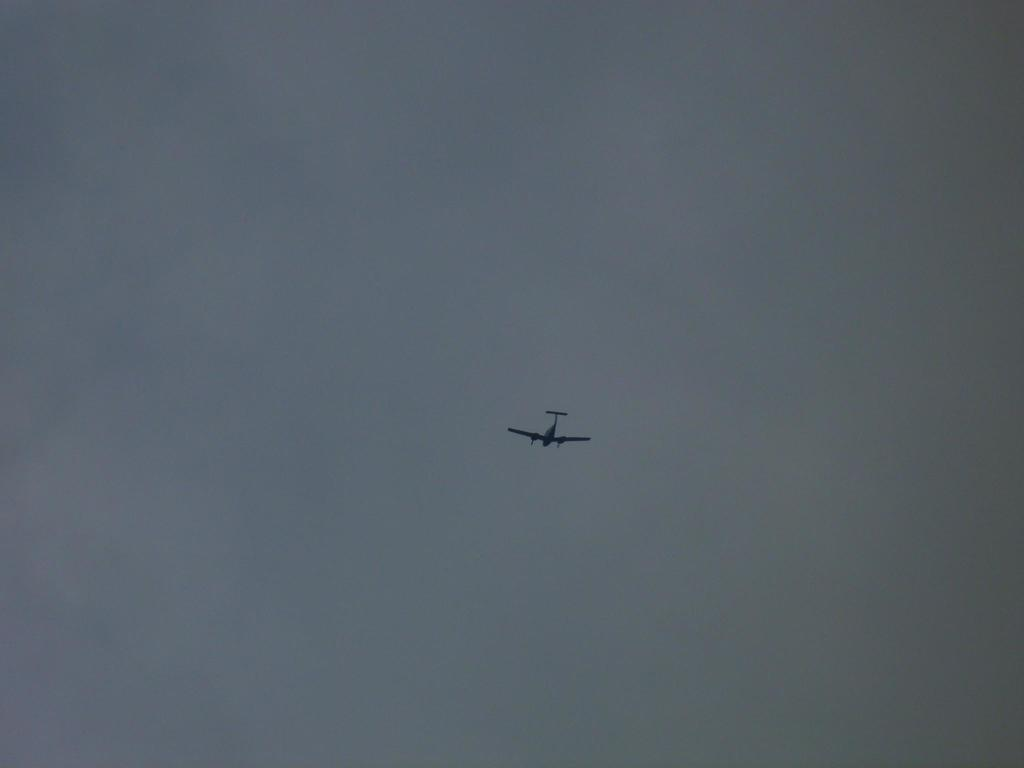What is the main subject in the foreground of the image? There is a plane in the air in the foreground of the image. What can be seen in the background of the image? The sky is visible in the background of the image. What type of nail is being used to hold the plate in the image? There is no nail or plate present in the image; it features a plane in the air and the sky in the background. 